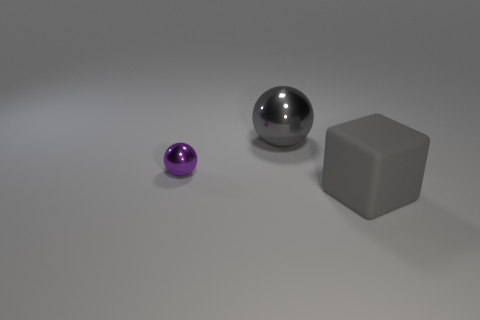There is a large gray thing in front of the metallic thing that is in front of the metal sphere behind the tiny thing; what is it made of?
Your response must be concise. Rubber. What is the size of the object that is to the left of the gray rubber object and in front of the gray metal sphere?
Your response must be concise. Small. Do the small purple object and the gray matte thing have the same shape?
Ensure brevity in your answer.  No. There is a purple object that is made of the same material as the large ball; what shape is it?
Keep it short and to the point. Sphere. How many small things are gray metal objects or brown rubber cubes?
Offer a terse response. 0. There is a large object that is behind the matte cube; is there a gray object on the left side of it?
Provide a short and direct response. No. Are there any blue spheres?
Your answer should be very brief. No. The big thing that is behind the thing right of the big ball is what color?
Your answer should be compact. Gray. What number of other rubber cubes are the same size as the gray matte cube?
Give a very brief answer. 0. There is a gray ball that is the same material as the purple ball; what is its size?
Keep it short and to the point. Large. 